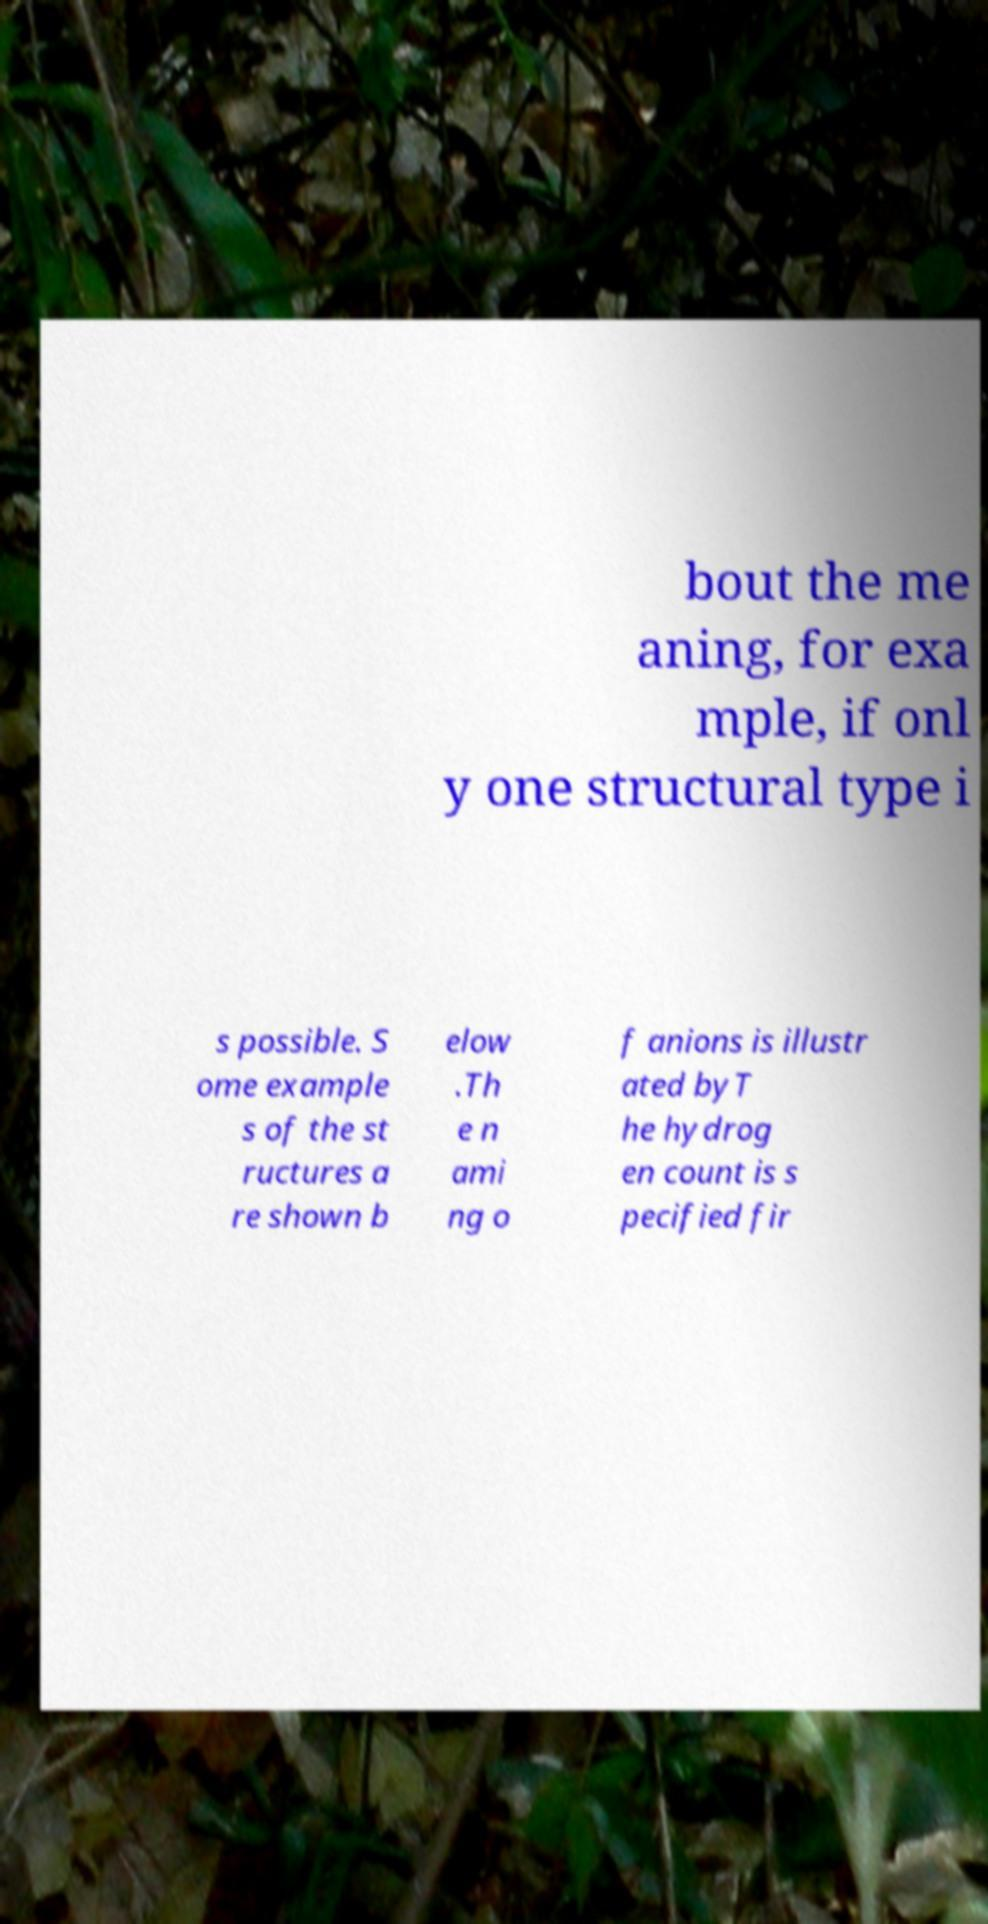There's text embedded in this image that I need extracted. Can you transcribe it verbatim? bout the me aning, for exa mple, if onl y one structural type i s possible. S ome example s of the st ructures a re shown b elow .Th e n ami ng o f anions is illustr ated byT he hydrog en count is s pecified fir 